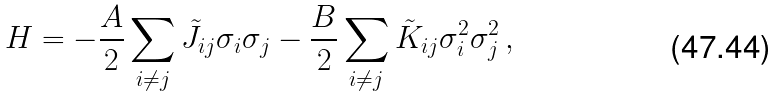Convert formula to latex. <formula><loc_0><loc_0><loc_500><loc_500>H = - \frac { A } { 2 } \sum _ { i \neq j } \tilde { J } _ { i j } \sigma _ { i } \sigma _ { j } - \frac { B } { 2 } \sum _ { i \neq j } \tilde { K } _ { i j } \sigma _ { i } ^ { 2 } \sigma _ { j } ^ { 2 } \, ,</formula> 